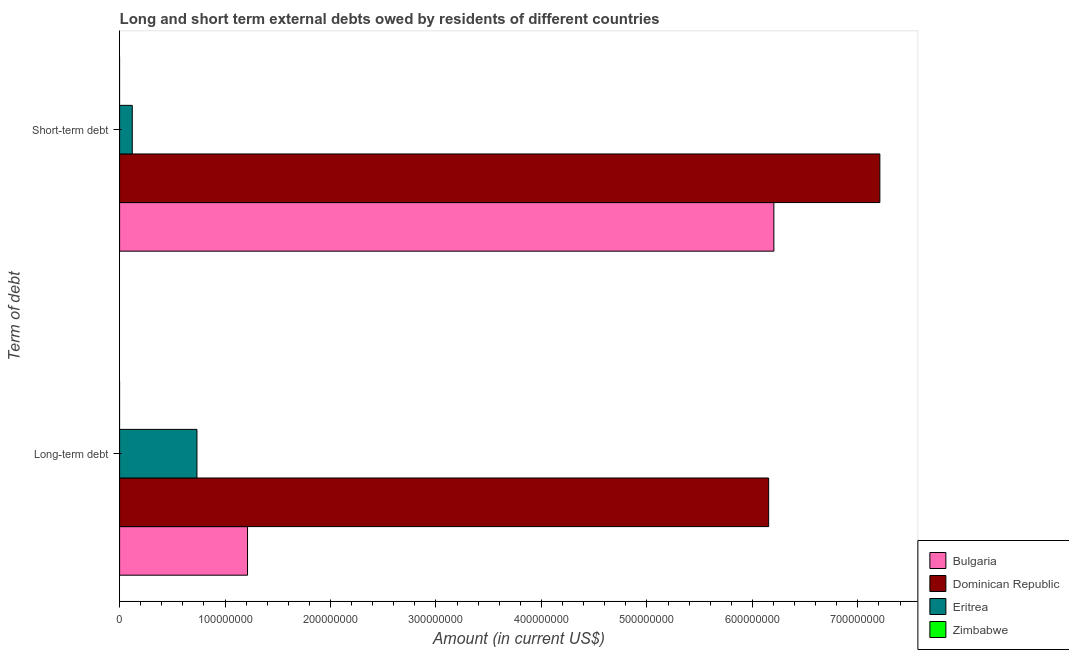How many groups of bars are there?
Provide a short and direct response. 2. Are the number of bars per tick equal to the number of legend labels?
Your answer should be compact. No. Are the number of bars on each tick of the Y-axis equal?
Your answer should be very brief. Yes. How many bars are there on the 2nd tick from the bottom?
Your response must be concise. 3. What is the label of the 2nd group of bars from the top?
Your answer should be compact. Long-term debt. What is the long-term debts owed by residents in Zimbabwe?
Make the answer very short. 0. Across all countries, what is the maximum long-term debts owed by residents?
Provide a succinct answer. 6.15e+08. Across all countries, what is the minimum short-term debts owed by residents?
Offer a very short reply. 0. In which country was the short-term debts owed by residents maximum?
Offer a very short reply. Dominican Republic. What is the total long-term debts owed by residents in the graph?
Your answer should be compact. 8.10e+08. What is the difference between the long-term debts owed by residents in Eritrea and that in Dominican Republic?
Ensure brevity in your answer.  -5.42e+08. What is the difference between the long-term debts owed by residents in Bulgaria and the short-term debts owed by residents in Zimbabwe?
Your answer should be compact. 1.21e+08. What is the average long-term debts owed by residents per country?
Offer a terse response. 2.03e+08. What is the difference between the long-term debts owed by residents and short-term debts owed by residents in Dominican Republic?
Ensure brevity in your answer.  -1.05e+08. What is the ratio of the short-term debts owed by residents in Bulgaria to that in Eritrea?
Offer a very short reply. 51.7. Are all the bars in the graph horizontal?
Keep it short and to the point. Yes. What is the difference between two consecutive major ticks on the X-axis?
Your answer should be very brief. 1.00e+08. Are the values on the major ticks of X-axis written in scientific E-notation?
Give a very brief answer. No. Does the graph contain grids?
Keep it short and to the point. No. Where does the legend appear in the graph?
Make the answer very short. Bottom right. How are the legend labels stacked?
Provide a succinct answer. Vertical. What is the title of the graph?
Ensure brevity in your answer.  Long and short term external debts owed by residents of different countries. What is the label or title of the Y-axis?
Keep it short and to the point. Term of debt. What is the Amount (in current US$) of Bulgaria in Long-term debt?
Your answer should be compact. 1.21e+08. What is the Amount (in current US$) in Dominican Republic in Long-term debt?
Your answer should be very brief. 6.15e+08. What is the Amount (in current US$) of Eritrea in Long-term debt?
Provide a succinct answer. 7.33e+07. What is the Amount (in current US$) of Bulgaria in Short-term debt?
Provide a short and direct response. 6.20e+08. What is the Amount (in current US$) of Dominican Republic in Short-term debt?
Give a very brief answer. 7.21e+08. Across all Term of debt, what is the maximum Amount (in current US$) of Bulgaria?
Provide a succinct answer. 6.20e+08. Across all Term of debt, what is the maximum Amount (in current US$) in Dominican Republic?
Give a very brief answer. 7.21e+08. Across all Term of debt, what is the maximum Amount (in current US$) in Eritrea?
Keep it short and to the point. 7.33e+07. Across all Term of debt, what is the minimum Amount (in current US$) in Bulgaria?
Offer a terse response. 1.21e+08. Across all Term of debt, what is the minimum Amount (in current US$) of Dominican Republic?
Provide a short and direct response. 6.15e+08. Across all Term of debt, what is the minimum Amount (in current US$) of Eritrea?
Your answer should be very brief. 1.20e+07. What is the total Amount (in current US$) of Bulgaria in the graph?
Give a very brief answer. 7.42e+08. What is the total Amount (in current US$) of Dominican Republic in the graph?
Make the answer very short. 1.34e+09. What is the total Amount (in current US$) in Eritrea in the graph?
Your response must be concise. 8.53e+07. What is the total Amount (in current US$) in Zimbabwe in the graph?
Ensure brevity in your answer.  0. What is the difference between the Amount (in current US$) of Bulgaria in Long-term debt and that in Short-term debt?
Offer a very short reply. -4.99e+08. What is the difference between the Amount (in current US$) of Dominican Republic in Long-term debt and that in Short-term debt?
Your answer should be compact. -1.05e+08. What is the difference between the Amount (in current US$) in Eritrea in Long-term debt and that in Short-term debt?
Your answer should be compact. 6.13e+07. What is the difference between the Amount (in current US$) in Bulgaria in Long-term debt and the Amount (in current US$) in Dominican Republic in Short-term debt?
Ensure brevity in your answer.  -6.00e+08. What is the difference between the Amount (in current US$) in Bulgaria in Long-term debt and the Amount (in current US$) in Eritrea in Short-term debt?
Make the answer very short. 1.09e+08. What is the difference between the Amount (in current US$) in Dominican Republic in Long-term debt and the Amount (in current US$) in Eritrea in Short-term debt?
Your response must be concise. 6.03e+08. What is the average Amount (in current US$) in Bulgaria per Term of debt?
Your answer should be compact. 3.71e+08. What is the average Amount (in current US$) of Dominican Republic per Term of debt?
Provide a succinct answer. 6.68e+08. What is the average Amount (in current US$) in Eritrea per Term of debt?
Ensure brevity in your answer.  4.27e+07. What is the average Amount (in current US$) of Zimbabwe per Term of debt?
Offer a terse response. 0. What is the difference between the Amount (in current US$) of Bulgaria and Amount (in current US$) of Dominican Republic in Long-term debt?
Keep it short and to the point. -4.94e+08. What is the difference between the Amount (in current US$) of Bulgaria and Amount (in current US$) of Eritrea in Long-term debt?
Make the answer very short. 4.80e+07. What is the difference between the Amount (in current US$) in Dominican Republic and Amount (in current US$) in Eritrea in Long-term debt?
Your answer should be very brief. 5.42e+08. What is the difference between the Amount (in current US$) of Bulgaria and Amount (in current US$) of Dominican Republic in Short-term debt?
Offer a very short reply. -1.00e+08. What is the difference between the Amount (in current US$) of Bulgaria and Amount (in current US$) of Eritrea in Short-term debt?
Provide a short and direct response. 6.08e+08. What is the difference between the Amount (in current US$) of Dominican Republic and Amount (in current US$) of Eritrea in Short-term debt?
Provide a succinct answer. 7.09e+08. What is the ratio of the Amount (in current US$) in Bulgaria in Long-term debt to that in Short-term debt?
Make the answer very short. 0.2. What is the ratio of the Amount (in current US$) of Dominican Republic in Long-term debt to that in Short-term debt?
Offer a very short reply. 0.85. What is the ratio of the Amount (in current US$) of Eritrea in Long-term debt to that in Short-term debt?
Offer a very short reply. 6.11. What is the difference between the highest and the second highest Amount (in current US$) in Bulgaria?
Ensure brevity in your answer.  4.99e+08. What is the difference between the highest and the second highest Amount (in current US$) of Dominican Republic?
Ensure brevity in your answer.  1.05e+08. What is the difference between the highest and the second highest Amount (in current US$) in Eritrea?
Your response must be concise. 6.13e+07. What is the difference between the highest and the lowest Amount (in current US$) of Bulgaria?
Offer a very short reply. 4.99e+08. What is the difference between the highest and the lowest Amount (in current US$) of Dominican Republic?
Provide a short and direct response. 1.05e+08. What is the difference between the highest and the lowest Amount (in current US$) of Eritrea?
Offer a very short reply. 6.13e+07. 